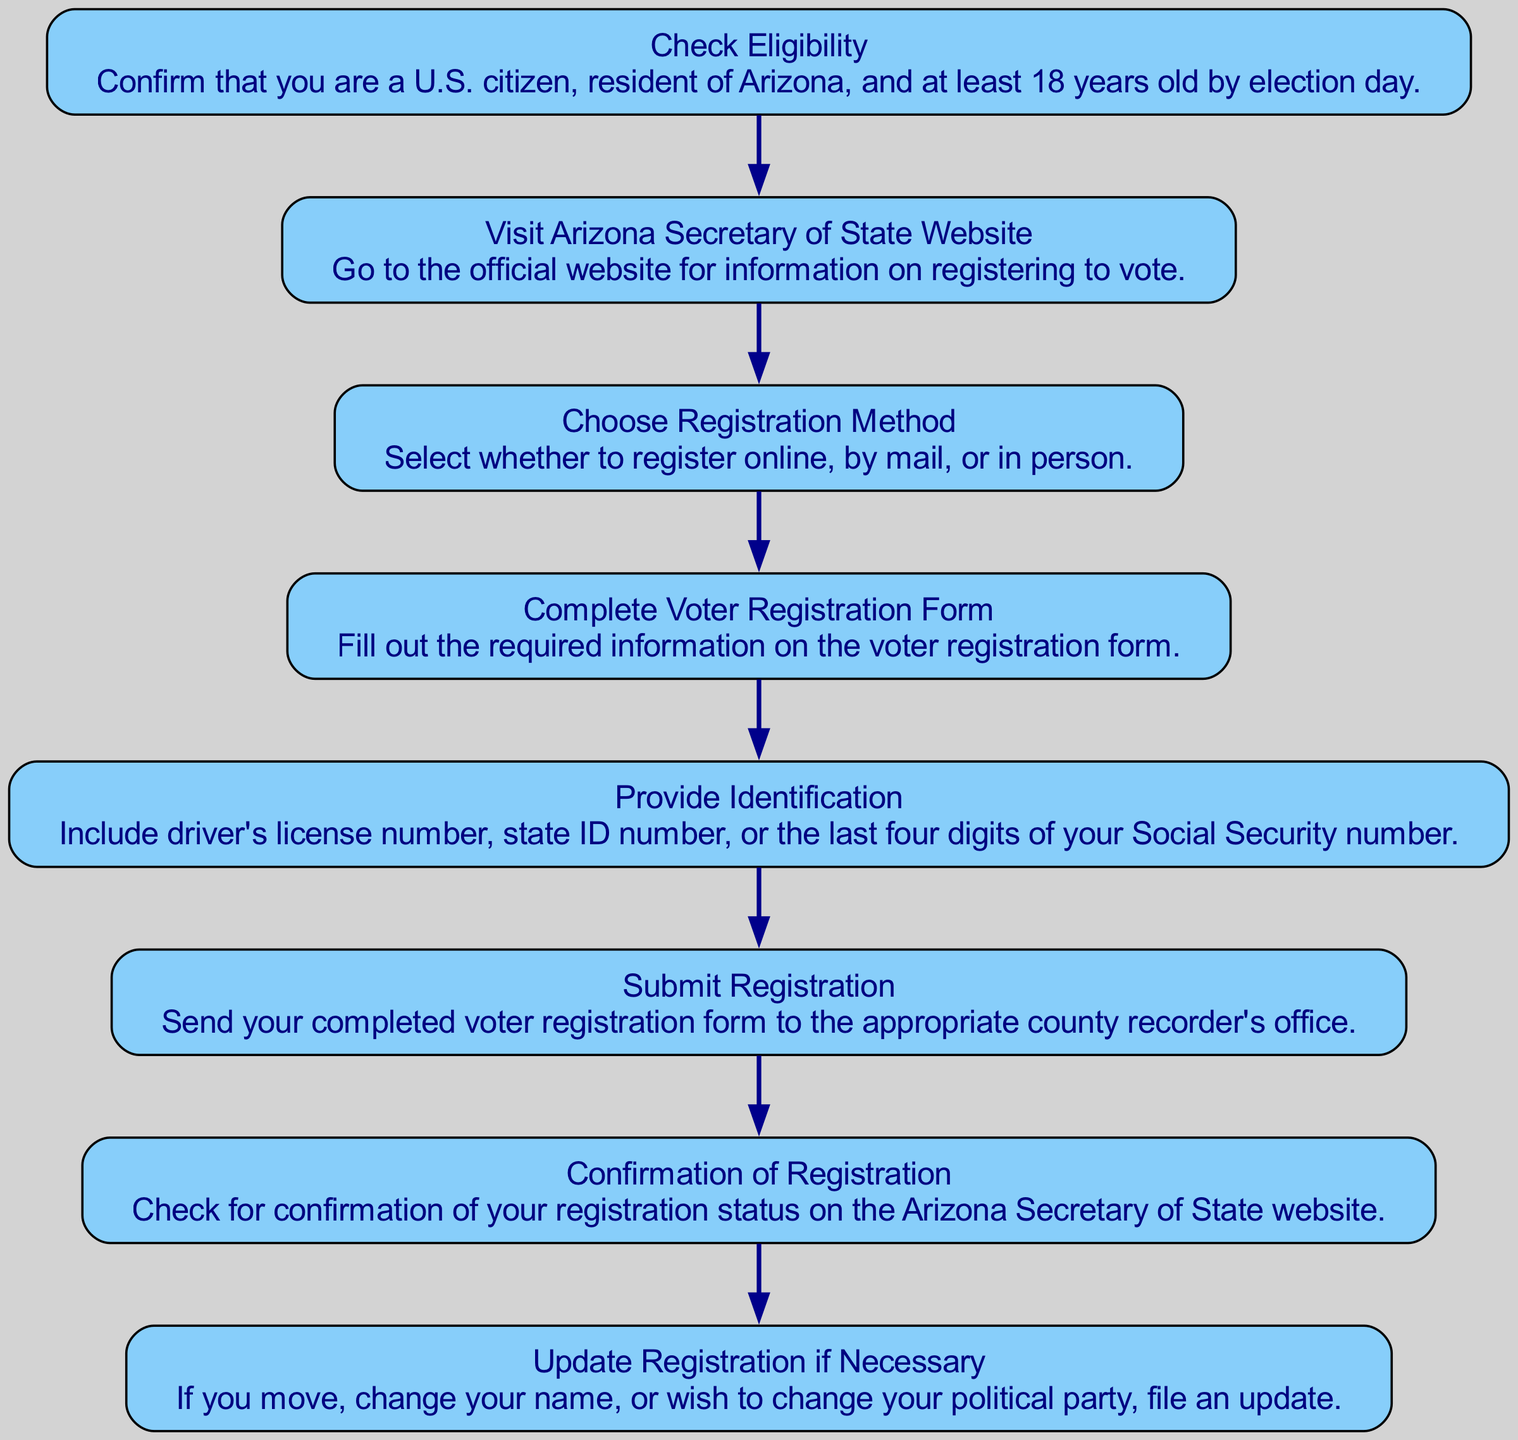What is the first step in the process? The first step in the flow chart is labeled "Check Eligibility," which involves confirming that one meets the basic requirements to register to vote in Arizona. This can be found at the top of the chart, indicating the starting point of the process.
Answer: Check Eligibility What must you visit to start registering? The diagram specifies that one must "Visit Arizona Secretary of State Website" as the second step, and this node directly follows the first step, indicating what should follow checking eligibility.
Answer: Visit Arizona Secretary of State Website How many total steps are there in the process? By counting the nodes in the diagram, there are a total of eight distinct steps, each represented by a node that outlines a part of the voter registration process.
Answer: Eight What information is provided in the "Complete Voter Registration Form" step? The node for "Complete Voter Registration Form" describes the requirement to fill out the necessary information on this form. This information is directly provided in the node and indicates the action to be taken at this point.
Answer: Fill out the required information on the voter registration form What should you provide in the "Provide Identification" step? The "Provide Identification" step requires including your driver's license number, state ID number, or the last four digits of your Social Security number, as detailed in that particular node.
Answer: Driver's license number, state ID number, or the last four digits of your Social Security number How does "Update Registration if Necessary" relate to the rest of the flow? "Update Registration if Necessary" occurs after receiving confirmation of registration and indicates that if there are changes such as moving or changing a name or political party, you should file an update. This implies an ongoing requirement for maintaining accurate voter registration.
Answer: It indicates ongoing maintenance of registration In which step do you check for confirmation of registration? According to the diagram, you check for confirmation of registration in the seventh step, which is labeled "Confirmation of Registration," showing it is essential to verify your registration status after submission.
Answer: Confirmation of Registration What is necessary to "Submit Registration"? The "Submit Registration" step indicates that you need to send your completed voter registration form to the appropriate county recorder's office, as mentioned in the description of that node, clarifying the action required.
Answer: Send your completed voter registration form to the appropriate county recorder's office 